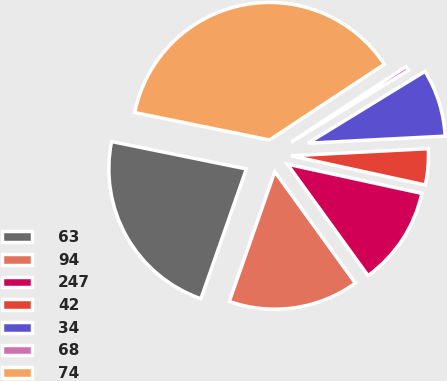<chart> <loc_0><loc_0><loc_500><loc_500><pie_chart><fcel>63<fcel>94<fcel>247<fcel>42<fcel>34<fcel>68<fcel>74<nl><fcel>22.83%<fcel>15.33%<fcel>11.63%<fcel>4.23%<fcel>7.93%<fcel>0.52%<fcel>37.54%<nl></chart> 